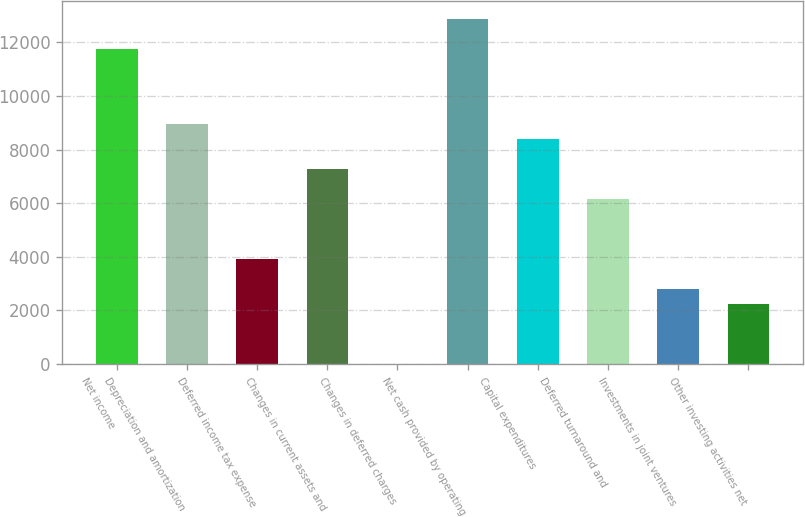Convert chart. <chart><loc_0><loc_0><loc_500><loc_500><bar_chart><fcel>Net income<fcel>Depreciation and amortization<fcel>Deferred income tax expense<fcel>Changes in current assets and<fcel>Changes in deferred charges<fcel>Net cash provided by operating<fcel>Capital expenditures<fcel>Deferred turnaround and<fcel>Investments in joint ventures<fcel>Other investing activities net<nl><fcel>11762.2<fcel>8966.2<fcel>3933.4<fcel>7288.6<fcel>19<fcel>12880.6<fcel>8407<fcel>6170.2<fcel>2815<fcel>2255.8<nl></chart> 